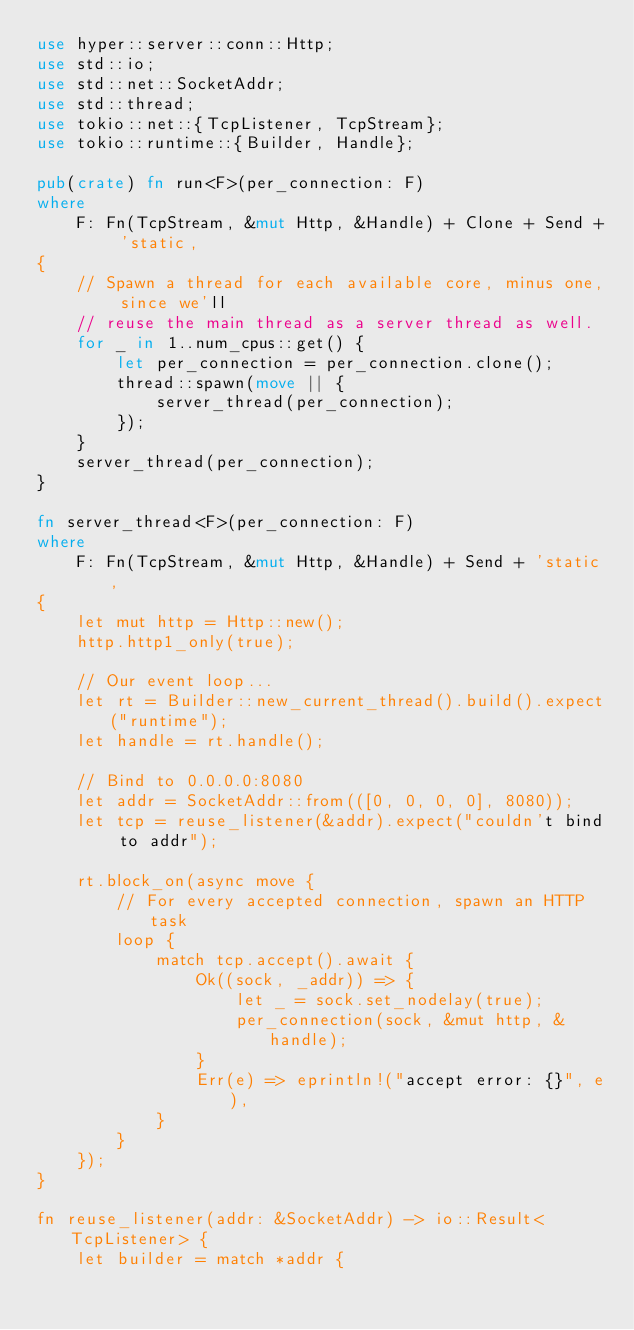Convert code to text. <code><loc_0><loc_0><loc_500><loc_500><_Rust_>use hyper::server::conn::Http;
use std::io;
use std::net::SocketAddr;
use std::thread;
use tokio::net::{TcpListener, TcpStream};
use tokio::runtime::{Builder, Handle};

pub(crate) fn run<F>(per_connection: F)
where
    F: Fn(TcpStream, &mut Http, &Handle) + Clone + Send + 'static,
{
    // Spawn a thread for each available core, minus one, since we'll
    // reuse the main thread as a server thread as well.
    for _ in 1..num_cpus::get() {
        let per_connection = per_connection.clone();
        thread::spawn(move || {
            server_thread(per_connection);
        });
    }
    server_thread(per_connection);
}

fn server_thread<F>(per_connection: F)
where
    F: Fn(TcpStream, &mut Http, &Handle) + Send + 'static,
{
    let mut http = Http::new();
    http.http1_only(true);

    // Our event loop...
    let rt = Builder::new_current_thread().build().expect("runtime");
    let handle = rt.handle();

    // Bind to 0.0.0.0:8080
    let addr = SocketAddr::from(([0, 0, 0, 0], 8080));
    let tcp = reuse_listener(&addr).expect("couldn't bind to addr");

    rt.block_on(async move {
        // For every accepted connection, spawn an HTTP task
        loop {
            match tcp.accept().await {
                Ok((sock, _addr)) => {
                    let _ = sock.set_nodelay(true);
                    per_connection(sock, &mut http, &handle);
                }
                Err(e) => eprintln!("accept error: {}", e),
            }
        }
    });
}

fn reuse_listener(addr: &SocketAddr) -> io::Result<TcpListener> {
    let builder = match *addr {</code> 